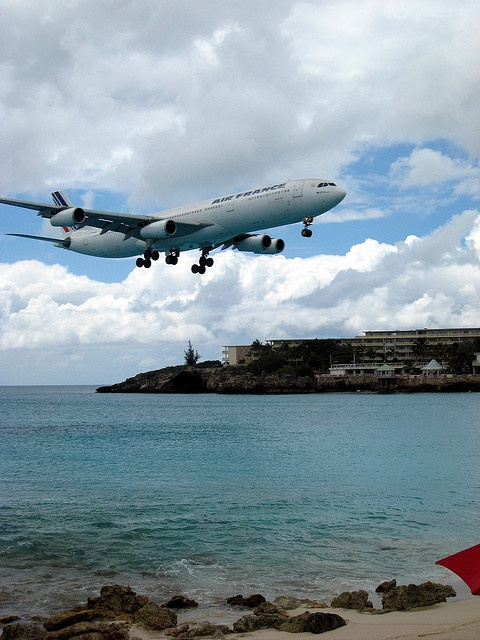Describe the objects in this image and their specific colors. I can see a airplane in lavender, blue, black, darkgray, and gray tones in this image. 